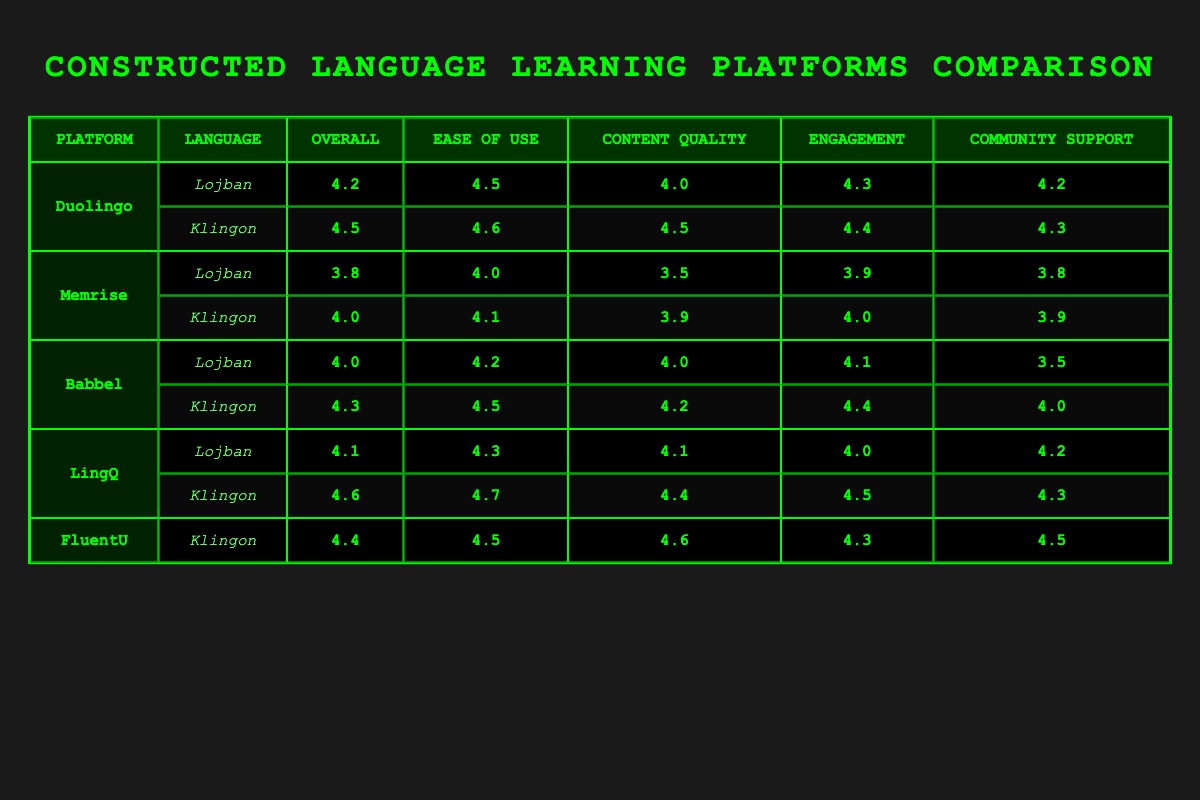What is the overall satisfaction rating for Lojban on Duolingo? The table shows that the overall satisfaction rating for Lojban on Duolingo is 4.2
Answer: 4.2 Which platform has the highest ease of use rating for Klingon? By comparing the ease of use ratings for Klingon across the platforms, LingQ has the highest rating of 4.7
Answer: 4.7 What is the average content quality rating for Lojban across all platforms? The content quality ratings for Lojban are 4.0 (Duolingo), 3.5 (Memrise), 4.0 (Babbel), and 4.1 (LingQ). The average is calculated as (4.0 + 3.5 + 4.0 + 4.1) / 4 = 3.9
Answer: 3.9 Does FluentU provide a satisfaction rating for Lojban? According to the table, FluentU only includes a satisfaction rating for Klingon and does not provide one for Lojban
Answer: No What is the difference between the engagement ratings for Klingon on Memrise and Duolingo? The engagement rating for Klingon on Memrise is 4.0 and on Duolingo is 4.4. The difference is 4.4 - 4.0 = 0.4
Answer: 0.4 What platform offers the best overall satisfaction rating for Klingon? From the table, LingQ has the best overall satisfaction rating for Klingon at 4.6
Answer: 4.6 Is the community support rating for Lojban on Babbel more than 3? The table shows that the community support rating for Lojban on Babbel is 3.5, which is not more than 3
Answer: No Compare the overall satisfaction ratings of Lojban on Memrise and Babbel. Which one is higher? The overall satisfaction rating for Lojban on Memrise is 3.8 and on Babbel is 4.0. Babbel's rating is higher
Answer: Babbel What is the median ease of use rating for Klingon across all reported platforms? The ease of use ratings for Klingon are 4.6 (Duolingo), 4.1 (Memrise), 4.5 (Babbel), 4.7 (LingQ), and 4.5 (FluentU), sorted they are 4.1, 4.5, 4.5, 4.6, 4.7. The median value is 4.5
Answer: 4.5 Which platform provides the lowest content quality rating for Lojban? By examining the content quality ratings for Lojban, Memrise has the lowest at 3.5
Answer: 3.5 